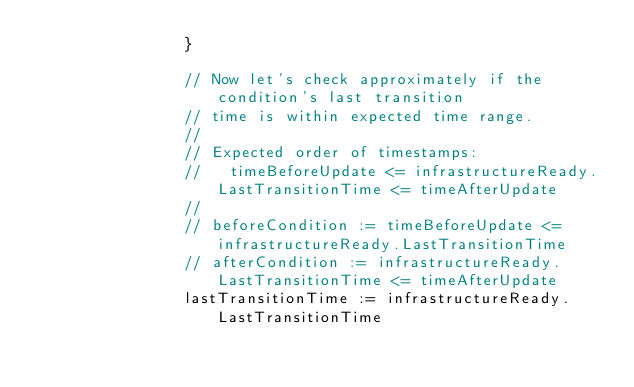<code> <loc_0><loc_0><loc_500><loc_500><_Go_>				}

				// Now let's check approximately if the condition's last transition
				// time is within expected time range.
				//
				// Expected order of timestamps:
				//   timeBeforeUpdate <= infrastructureReady.LastTransitionTime <= timeAfterUpdate
				//
				// beforeCondition := timeBeforeUpdate <= infrastructureReady.LastTransitionTime
				// afterCondition := infrastructureReady.LastTransitionTime <= timeAfterUpdate
				lastTransitionTime := infrastructureReady.LastTransitionTime</code> 